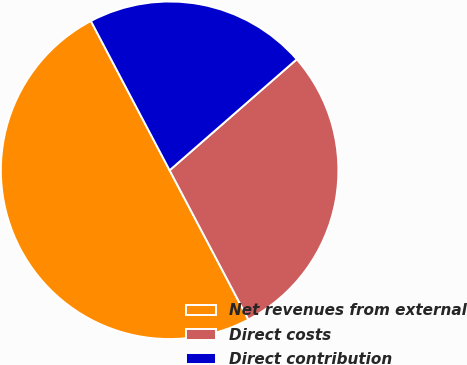Convert chart to OTSL. <chart><loc_0><loc_0><loc_500><loc_500><pie_chart><fcel>Net revenues from external<fcel>Direct costs<fcel>Direct contribution<nl><fcel>50.0%<fcel>28.7%<fcel>21.3%<nl></chart> 